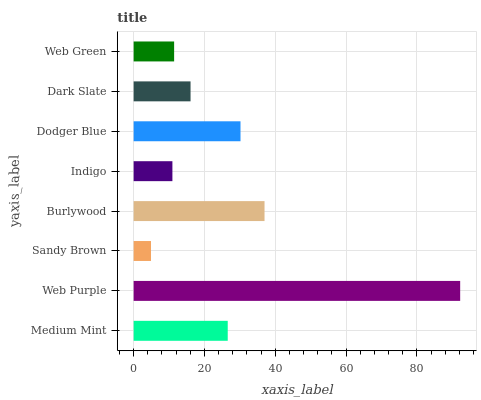Is Sandy Brown the minimum?
Answer yes or no. Yes. Is Web Purple the maximum?
Answer yes or no. Yes. Is Web Purple the minimum?
Answer yes or no. No. Is Sandy Brown the maximum?
Answer yes or no. No. Is Web Purple greater than Sandy Brown?
Answer yes or no. Yes. Is Sandy Brown less than Web Purple?
Answer yes or no. Yes. Is Sandy Brown greater than Web Purple?
Answer yes or no. No. Is Web Purple less than Sandy Brown?
Answer yes or no. No. Is Medium Mint the high median?
Answer yes or no. Yes. Is Dark Slate the low median?
Answer yes or no. Yes. Is Indigo the high median?
Answer yes or no. No. Is Web Green the low median?
Answer yes or no. No. 